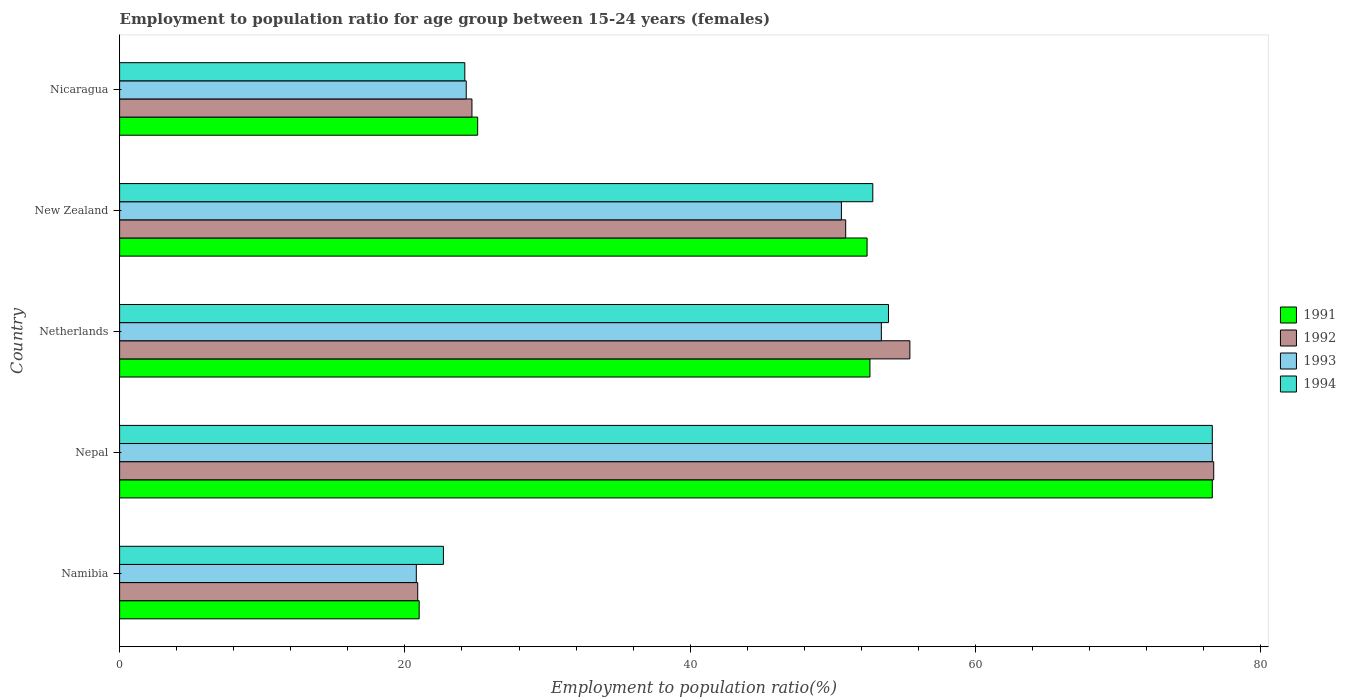How many groups of bars are there?
Give a very brief answer. 5. How many bars are there on the 2nd tick from the bottom?
Ensure brevity in your answer.  4. What is the label of the 1st group of bars from the top?
Your answer should be very brief. Nicaragua. What is the employment to population ratio in 1994 in Nicaragua?
Ensure brevity in your answer.  24.2. Across all countries, what is the maximum employment to population ratio in 1992?
Your answer should be very brief. 76.7. Across all countries, what is the minimum employment to population ratio in 1994?
Your answer should be compact. 22.7. In which country was the employment to population ratio in 1991 maximum?
Ensure brevity in your answer.  Nepal. In which country was the employment to population ratio in 1991 minimum?
Offer a terse response. Namibia. What is the total employment to population ratio in 1992 in the graph?
Offer a very short reply. 228.6. What is the difference between the employment to population ratio in 1991 in New Zealand and that in Nicaragua?
Your response must be concise. 27.3. What is the difference between the employment to population ratio in 1994 in Nepal and the employment to population ratio in 1992 in Netherlands?
Your answer should be compact. 21.2. What is the average employment to population ratio in 1992 per country?
Ensure brevity in your answer.  45.72. What is the difference between the employment to population ratio in 1991 and employment to population ratio in 1993 in New Zealand?
Provide a succinct answer. 1.8. In how many countries, is the employment to population ratio in 1993 greater than 20 %?
Offer a very short reply. 5. What is the ratio of the employment to population ratio in 1994 in Namibia to that in Netherlands?
Make the answer very short. 0.42. Is the employment to population ratio in 1991 in New Zealand less than that in Nicaragua?
Provide a succinct answer. No. Is the difference between the employment to population ratio in 1991 in Netherlands and Nicaragua greater than the difference between the employment to population ratio in 1993 in Netherlands and Nicaragua?
Offer a terse response. No. What is the difference between the highest and the second highest employment to population ratio in 1992?
Ensure brevity in your answer.  21.3. What is the difference between the highest and the lowest employment to population ratio in 1993?
Ensure brevity in your answer.  55.8. Is the sum of the employment to population ratio in 1993 in Namibia and New Zealand greater than the maximum employment to population ratio in 1992 across all countries?
Give a very brief answer. No. Are all the bars in the graph horizontal?
Your response must be concise. Yes. How many countries are there in the graph?
Offer a terse response. 5. What is the difference between two consecutive major ticks on the X-axis?
Offer a very short reply. 20. Are the values on the major ticks of X-axis written in scientific E-notation?
Offer a very short reply. No. Does the graph contain any zero values?
Your response must be concise. No. How many legend labels are there?
Your answer should be very brief. 4. What is the title of the graph?
Keep it short and to the point. Employment to population ratio for age group between 15-24 years (females). Does "1987" appear as one of the legend labels in the graph?
Keep it short and to the point. No. What is the label or title of the X-axis?
Your answer should be very brief. Employment to population ratio(%). What is the Employment to population ratio(%) in 1991 in Namibia?
Give a very brief answer. 21. What is the Employment to population ratio(%) in 1992 in Namibia?
Make the answer very short. 20.9. What is the Employment to population ratio(%) of 1993 in Namibia?
Your answer should be compact. 20.8. What is the Employment to population ratio(%) in 1994 in Namibia?
Your answer should be compact. 22.7. What is the Employment to population ratio(%) of 1991 in Nepal?
Your answer should be compact. 76.6. What is the Employment to population ratio(%) in 1992 in Nepal?
Offer a terse response. 76.7. What is the Employment to population ratio(%) in 1993 in Nepal?
Make the answer very short. 76.6. What is the Employment to population ratio(%) in 1994 in Nepal?
Your answer should be very brief. 76.6. What is the Employment to population ratio(%) of 1991 in Netherlands?
Keep it short and to the point. 52.6. What is the Employment to population ratio(%) in 1992 in Netherlands?
Provide a succinct answer. 55.4. What is the Employment to population ratio(%) of 1993 in Netherlands?
Give a very brief answer. 53.4. What is the Employment to population ratio(%) of 1994 in Netherlands?
Provide a succinct answer. 53.9. What is the Employment to population ratio(%) in 1991 in New Zealand?
Offer a terse response. 52.4. What is the Employment to population ratio(%) of 1992 in New Zealand?
Give a very brief answer. 50.9. What is the Employment to population ratio(%) in 1993 in New Zealand?
Provide a short and direct response. 50.6. What is the Employment to population ratio(%) of 1994 in New Zealand?
Your answer should be very brief. 52.8. What is the Employment to population ratio(%) in 1991 in Nicaragua?
Make the answer very short. 25.1. What is the Employment to population ratio(%) in 1992 in Nicaragua?
Your response must be concise. 24.7. What is the Employment to population ratio(%) of 1993 in Nicaragua?
Give a very brief answer. 24.3. What is the Employment to population ratio(%) of 1994 in Nicaragua?
Ensure brevity in your answer.  24.2. Across all countries, what is the maximum Employment to population ratio(%) of 1991?
Your answer should be very brief. 76.6. Across all countries, what is the maximum Employment to population ratio(%) in 1992?
Ensure brevity in your answer.  76.7. Across all countries, what is the maximum Employment to population ratio(%) of 1993?
Make the answer very short. 76.6. Across all countries, what is the maximum Employment to population ratio(%) in 1994?
Offer a very short reply. 76.6. Across all countries, what is the minimum Employment to population ratio(%) of 1991?
Offer a terse response. 21. Across all countries, what is the minimum Employment to population ratio(%) of 1992?
Make the answer very short. 20.9. Across all countries, what is the minimum Employment to population ratio(%) in 1993?
Give a very brief answer. 20.8. Across all countries, what is the minimum Employment to population ratio(%) in 1994?
Your answer should be very brief. 22.7. What is the total Employment to population ratio(%) of 1991 in the graph?
Give a very brief answer. 227.7. What is the total Employment to population ratio(%) of 1992 in the graph?
Your answer should be very brief. 228.6. What is the total Employment to population ratio(%) in 1993 in the graph?
Your answer should be compact. 225.7. What is the total Employment to population ratio(%) in 1994 in the graph?
Ensure brevity in your answer.  230.2. What is the difference between the Employment to population ratio(%) in 1991 in Namibia and that in Nepal?
Offer a very short reply. -55.6. What is the difference between the Employment to population ratio(%) in 1992 in Namibia and that in Nepal?
Make the answer very short. -55.8. What is the difference between the Employment to population ratio(%) in 1993 in Namibia and that in Nepal?
Offer a very short reply. -55.8. What is the difference between the Employment to population ratio(%) of 1994 in Namibia and that in Nepal?
Make the answer very short. -53.9. What is the difference between the Employment to population ratio(%) in 1991 in Namibia and that in Netherlands?
Your answer should be compact. -31.6. What is the difference between the Employment to population ratio(%) of 1992 in Namibia and that in Netherlands?
Provide a succinct answer. -34.5. What is the difference between the Employment to population ratio(%) of 1993 in Namibia and that in Netherlands?
Give a very brief answer. -32.6. What is the difference between the Employment to population ratio(%) of 1994 in Namibia and that in Netherlands?
Keep it short and to the point. -31.2. What is the difference between the Employment to population ratio(%) in 1991 in Namibia and that in New Zealand?
Provide a succinct answer. -31.4. What is the difference between the Employment to population ratio(%) of 1992 in Namibia and that in New Zealand?
Offer a very short reply. -30. What is the difference between the Employment to population ratio(%) of 1993 in Namibia and that in New Zealand?
Provide a short and direct response. -29.8. What is the difference between the Employment to population ratio(%) in 1994 in Namibia and that in New Zealand?
Offer a very short reply. -30.1. What is the difference between the Employment to population ratio(%) in 1992 in Namibia and that in Nicaragua?
Offer a very short reply. -3.8. What is the difference between the Employment to population ratio(%) in 1993 in Namibia and that in Nicaragua?
Ensure brevity in your answer.  -3.5. What is the difference between the Employment to population ratio(%) of 1992 in Nepal and that in Netherlands?
Your response must be concise. 21.3. What is the difference between the Employment to population ratio(%) of 1993 in Nepal and that in Netherlands?
Offer a very short reply. 23.2. What is the difference between the Employment to population ratio(%) of 1994 in Nepal and that in Netherlands?
Keep it short and to the point. 22.7. What is the difference between the Employment to population ratio(%) of 1991 in Nepal and that in New Zealand?
Provide a short and direct response. 24.2. What is the difference between the Employment to population ratio(%) of 1992 in Nepal and that in New Zealand?
Offer a terse response. 25.8. What is the difference between the Employment to population ratio(%) of 1993 in Nepal and that in New Zealand?
Your answer should be very brief. 26. What is the difference between the Employment to population ratio(%) of 1994 in Nepal and that in New Zealand?
Offer a terse response. 23.8. What is the difference between the Employment to population ratio(%) of 1991 in Nepal and that in Nicaragua?
Keep it short and to the point. 51.5. What is the difference between the Employment to population ratio(%) of 1993 in Nepal and that in Nicaragua?
Provide a short and direct response. 52.3. What is the difference between the Employment to population ratio(%) of 1994 in Nepal and that in Nicaragua?
Give a very brief answer. 52.4. What is the difference between the Employment to population ratio(%) of 1994 in Netherlands and that in New Zealand?
Give a very brief answer. 1.1. What is the difference between the Employment to population ratio(%) of 1991 in Netherlands and that in Nicaragua?
Ensure brevity in your answer.  27.5. What is the difference between the Employment to population ratio(%) in 1992 in Netherlands and that in Nicaragua?
Your answer should be very brief. 30.7. What is the difference between the Employment to population ratio(%) in 1993 in Netherlands and that in Nicaragua?
Provide a succinct answer. 29.1. What is the difference between the Employment to population ratio(%) in 1994 in Netherlands and that in Nicaragua?
Your answer should be very brief. 29.7. What is the difference between the Employment to population ratio(%) of 1991 in New Zealand and that in Nicaragua?
Offer a terse response. 27.3. What is the difference between the Employment to population ratio(%) of 1992 in New Zealand and that in Nicaragua?
Make the answer very short. 26.2. What is the difference between the Employment to population ratio(%) of 1993 in New Zealand and that in Nicaragua?
Keep it short and to the point. 26.3. What is the difference between the Employment to population ratio(%) in 1994 in New Zealand and that in Nicaragua?
Your answer should be compact. 28.6. What is the difference between the Employment to population ratio(%) of 1991 in Namibia and the Employment to population ratio(%) of 1992 in Nepal?
Offer a terse response. -55.7. What is the difference between the Employment to population ratio(%) in 1991 in Namibia and the Employment to population ratio(%) in 1993 in Nepal?
Provide a short and direct response. -55.6. What is the difference between the Employment to population ratio(%) of 1991 in Namibia and the Employment to population ratio(%) of 1994 in Nepal?
Provide a succinct answer. -55.6. What is the difference between the Employment to population ratio(%) in 1992 in Namibia and the Employment to population ratio(%) in 1993 in Nepal?
Your response must be concise. -55.7. What is the difference between the Employment to population ratio(%) in 1992 in Namibia and the Employment to population ratio(%) in 1994 in Nepal?
Ensure brevity in your answer.  -55.7. What is the difference between the Employment to population ratio(%) in 1993 in Namibia and the Employment to population ratio(%) in 1994 in Nepal?
Make the answer very short. -55.8. What is the difference between the Employment to population ratio(%) in 1991 in Namibia and the Employment to population ratio(%) in 1992 in Netherlands?
Your answer should be compact. -34.4. What is the difference between the Employment to population ratio(%) of 1991 in Namibia and the Employment to population ratio(%) of 1993 in Netherlands?
Give a very brief answer. -32.4. What is the difference between the Employment to population ratio(%) in 1991 in Namibia and the Employment to population ratio(%) in 1994 in Netherlands?
Provide a succinct answer. -32.9. What is the difference between the Employment to population ratio(%) in 1992 in Namibia and the Employment to population ratio(%) in 1993 in Netherlands?
Offer a very short reply. -32.5. What is the difference between the Employment to population ratio(%) in 1992 in Namibia and the Employment to population ratio(%) in 1994 in Netherlands?
Give a very brief answer. -33. What is the difference between the Employment to population ratio(%) of 1993 in Namibia and the Employment to population ratio(%) of 1994 in Netherlands?
Provide a succinct answer. -33.1. What is the difference between the Employment to population ratio(%) in 1991 in Namibia and the Employment to population ratio(%) in 1992 in New Zealand?
Keep it short and to the point. -29.9. What is the difference between the Employment to population ratio(%) of 1991 in Namibia and the Employment to population ratio(%) of 1993 in New Zealand?
Give a very brief answer. -29.6. What is the difference between the Employment to population ratio(%) of 1991 in Namibia and the Employment to population ratio(%) of 1994 in New Zealand?
Your answer should be compact. -31.8. What is the difference between the Employment to population ratio(%) in 1992 in Namibia and the Employment to population ratio(%) in 1993 in New Zealand?
Keep it short and to the point. -29.7. What is the difference between the Employment to population ratio(%) of 1992 in Namibia and the Employment to population ratio(%) of 1994 in New Zealand?
Offer a terse response. -31.9. What is the difference between the Employment to population ratio(%) of 1993 in Namibia and the Employment to population ratio(%) of 1994 in New Zealand?
Offer a terse response. -32. What is the difference between the Employment to population ratio(%) in 1991 in Namibia and the Employment to population ratio(%) in 1992 in Nicaragua?
Your response must be concise. -3.7. What is the difference between the Employment to population ratio(%) of 1992 in Namibia and the Employment to population ratio(%) of 1993 in Nicaragua?
Keep it short and to the point. -3.4. What is the difference between the Employment to population ratio(%) in 1992 in Namibia and the Employment to population ratio(%) in 1994 in Nicaragua?
Your response must be concise. -3.3. What is the difference between the Employment to population ratio(%) in 1993 in Namibia and the Employment to population ratio(%) in 1994 in Nicaragua?
Offer a very short reply. -3.4. What is the difference between the Employment to population ratio(%) in 1991 in Nepal and the Employment to population ratio(%) in 1992 in Netherlands?
Your response must be concise. 21.2. What is the difference between the Employment to population ratio(%) of 1991 in Nepal and the Employment to population ratio(%) of 1993 in Netherlands?
Your answer should be compact. 23.2. What is the difference between the Employment to population ratio(%) of 1991 in Nepal and the Employment to population ratio(%) of 1994 in Netherlands?
Provide a succinct answer. 22.7. What is the difference between the Employment to population ratio(%) in 1992 in Nepal and the Employment to population ratio(%) in 1993 in Netherlands?
Ensure brevity in your answer.  23.3. What is the difference between the Employment to population ratio(%) in 1992 in Nepal and the Employment to population ratio(%) in 1994 in Netherlands?
Keep it short and to the point. 22.8. What is the difference between the Employment to population ratio(%) of 1993 in Nepal and the Employment to population ratio(%) of 1994 in Netherlands?
Provide a short and direct response. 22.7. What is the difference between the Employment to population ratio(%) in 1991 in Nepal and the Employment to population ratio(%) in 1992 in New Zealand?
Ensure brevity in your answer.  25.7. What is the difference between the Employment to population ratio(%) in 1991 in Nepal and the Employment to population ratio(%) in 1994 in New Zealand?
Provide a succinct answer. 23.8. What is the difference between the Employment to population ratio(%) in 1992 in Nepal and the Employment to population ratio(%) in 1993 in New Zealand?
Provide a short and direct response. 26.1. What is the difference between the Employment to population ratio(%) in 1992 in Nepal and the Employment to population ratio(%) in 1994 in New Zealand?
Make the answer very short. 23.9. What is the difference between the Employment to population ratio(%) in 1993 in Nepal and the Employment to population ratio(%) in 1994 in New Zealand?
Offer a terse response. 23.8. What is the difference between the Employment to population ratio(%) of 1991 in Nepal and the Employment to population ratio(%) of 1992 in Nicaragua?
Keep it short and to the point. 51.9. What is the difference between the Employment to population ratio(%) of 1991 in Nepal and the Employment to population ratio(%) of 1993 in Nicaragua?
Give a very brief answer. 52.3. What is the difference between the Employment to population ratio(%) of 1991 in Nepal and the Employment to population ratio(%) of 1994 in Nicaragua?
Offer a terse response. 52.4. What is the difference between the Employment to population ratio(%) in 1992 in Nepal and the Employment to population ratio(%) in 1993 in Nicaragua?
Make the answer very short. 52.4. What is the difference between the Employment to population ratio(%) in 1992 in Nepal and the Employment to population ratio(%) in 1994 in Nicaragua?
Offer a terse response. 52.5. What is the difference between the Employment to population ratio(%) of 1993 in Nepal and the Employment to population ratio(%) of 1994 in Nicaragua?
Your answer should be compact. 52.4. What is the difference between the Employment to population ratio(%) in 1991 in Netherlands and the Employment to population ratio(%) in 1993 in New Zealand?
Ensure brevity in your answer.  2. What is the difference between the Employment to population ratio(%) of 1991 in Netherlands and the Employment to population ratio(%) of 1994 in New Zealand?
Give a very brief answer. -0.2. What is the difference between the Employment to population ratio(%) of 1992 in Netherlands and the Employment to population ratio(%) of 1994 in New Zealand?
Your response must be concise. 2.6. What is the difference between the Employment to population ratio(%) in 1991 in Netherlands and the Employment to population ratio(%) in 1992 in Nicaragua?
Offer a terse response. 27.9. What is the difference between the Employment to population ratio(%) of 1991 in Netherlands and the Employment to population ratio(%) of 1993 in Nicaragua?
Offer a terse response. 28.3. What is the difference between the Employment to population ratio(%) of 1991 in Netherlands and the Employment to population ratio(%) of 1994 in Nicaragua?
Your answer should be very brief. 28.4. What is the difference between the Employment to population ratio(%) of 1992 in Netherlands and the Employment to population ratio(%) of 1993 in Nicaragua?
Keep it short and to the point. 31.1. What is the difference between the Employment to population ratio(%) of 1992 in Netherlands and the Employment to population ratio(%) of 1994 in Nicaragua?
Give a very brief answer. 31.2. What is the difference between the Employment to population ratio(%) in 1993 in Netherlands and the Employment to population ratio(%) in 1994 in Nicaragua?
Your response must be concise. 29.2. What is the difference between the Employment to population ratio(%) in 1991 in New Zealand and the Employment to population ratio(%) in 1992 in Nicaragua?
Your response must be concise. 27.7. What is the difference between the Employment to population ratio(%) of 1991 in New Zealand and the Employment to population ratio(%) of 1993 in Nicaragua?
Give a very brief answer. 28.1. What is the difference between the Employment to population ratio(%) in 1991 in New Zealand and the Employment to population ratio(%) in 1994 in Nicaragua?
Provide a short and direct response. 28.2. What is the difference between the Employment to population ratio(%) in 1992 in New Zealand and the Employment to population ratio(%) in 1993 in Nicaragua?
Ensure brevity in your answer.  26.6. What is the difference between the Employment to population ratio(%) in 1992 in New Zealand and the Employment to population ratio(%) in 1994 in Nicaragua?
Provide a short and direct response. 26.7. What is the difference between the Employment to population ratio(%) in 1993 in New Zealand and the Employment to population ratio(%) in 1994 in Nicaragua?
Make the answer very short. 26.4. What is the average Employment to population ratio(%) in 1991 per country?
Make the answer very short. 45.54. What is the average Employment to population ratio(%) in 1992 per country?
Provide a succinct answer. 45.72. What is the average Employment to population ratio(%) of 1993 per country?
Offer a very short reply. 45.14. What is the average Employment to population ratio(%) of 1994 per country?
Your answer should be very brief. 46.04. What is the difference between the Employment to population ratio(%) of 1991 and Employment to population ratio(%) of 1992 in Namibia?
Offer a terse response. 0.1. What is the difference between the Employment to population ratio(%) in 1992 and Employment to population ratio(%) in 1994 in Namibia?
Your answer should be very brief. -1.8. What is the difference between the Employment to population ratio(%) in 1993 and Employment to population ratio(%) in 1994 in Namibia?
Offer a terse response. -1.9. What is the difference between the Employment to population ratio(%) in 1991 and Employment to population ratio(%) in 1992 in Nepal?
Provide a short and direct response. -0.1. What is the difference between the Employment to population ratio(%) of 1991 and Employment to population ratio(%) of 1993 in Nepal?
Your response must be concise. 0. What is the difference between the Employment to population ratio(%) in 1991 and Employment to population ratio(%) in 1992 in Netherlands?
Make the answer very short. -2.8. What is the difference between the Employment to population ratio(%) of 1992 and Employment to population ratio(%) of 1993 in Netherlands?
Offer a terse response. 2. What is the difference between the Employment to population ratio(%) in 1992 and Employment to population ratio(%) in 1994 in Netherlands?
Provide a short and direct response. 1.5. What is the difference between the Employment to population ratio(%) of 1991 and Employment to population ratio(%) of 1992 in New Zealand?
Make the answer very short. 1.5. What is the difference between the Employment to population ratio(%) in 1991 and Employment to population ratio(%) in 1993 in New Zealand?
Offer a very short reply. 1.8. What is the difference between the Employment to population ratio(%) of 1993 and Employment to population ratio(%) of 1994 in New Zealand?
Your answer should be very brief. -2.2. What is the difference between the Employment to population ratio(%) in 1991 and Employment to population ratio(%) in 1992 in Nicaragua?
Provide a succinct answer. 0.4. What is the difference between the Employment to population ratio(%) in 1991 and Employment to population ratio(%) in 1993 in Nicaragua?
Offer a terse response. 0.8. What is the difference between the Employment to population ratio(%) in 1991 and Employment to population ratio(%) in 1994 in Nicaragua?
Ensure brevity in your answer.  0.9. What is the difference between the Employment to population ratio(%) in 1992 and Employment to population ratio(%) in 1994 in Nicaragua?
Provide a short and direct response. 0.5. What is the difference between the Employment to population ratio(%) of 1993 and Employment to population ratio(%) of 1994 in Nicaragua?
Your answer should be compact. 0.1. What is the ratio of the Employment to population ratio(%) in 1991 in Namibia to that in Nepal?
Your response must be concise. 0.27. What is the ratio of the Employment to population ratio(%) in 1992 in Namibia to that in Nepal?
Your answer should be very brief. 0.27. What is the ratio of the Employment to population ratio(%) of 1993 in Namibia to that in Nepal?
Your response must be concise. 0.27. What is the ratio of the Employment to population ratio(%) of 1994 in Namibia to that in Nepal?
Your answer should be very brief. 0.3. What is the ratio of the Employment to population ratio(%) in 1991 in Namibia to that in Netherlands?
Make the answer very short. 0.4. What is the ratio of the Employment to population ratio(%) in 1992 in Namibia to that in Netherlands?
Your answer should be very brief. 0.38. What is the ratio of the Employment to population ratio(%) in 1993 in Namibia to that in Netherlands?
Provide a succinct answer. 0.39. What is the ratio of the Employment to population ratio(%) in 1994 in Namibia to that in Netherlands?
Ensure brevity in your answer.  0.42. What is the ratio of the Employment to population ratio(%) of 1991 in Namibia to that in New Zealand?
Your response must be concise. 0.4. What is the ratio of the Employment to population ratio(%) in 1992 in Namibia to that in New Zealand?
Keep it short and to the point. 0.41. What is the ratio of the Employment to population ratio(%) of 1993 in Namibia to that in New Zealand?
Provide a succinct answer. 0.41. What is the ratio of the Employment to population ratio(%) of 1994 in Namibia to that in New Zealand?
Your answer should be compact. 0.43. What is the ratio of the Employment to population ratio(%) in 1991 in Namibia to that in Nicaragua?
Ensure brevity in your answer.  0.84. What is the ratio of the Employment to population ratio(%) in 1992 in Namibia to that in Nicaragua?
Give a very brief answer. 0.85. What is the ratio of the Employment to population ratio(%) in 1993 in Namibia to that in Nicaragua?
Your response must be concise. 0.86. What is the ratio of the Employment to population ratio(%) of 1994 in Namibia to that in Nicaragua?
Your response must be concise. 0.94. What is the ratio of the Employment to population ratio(%) in 1991 in Nepal to that in Netherlands?
Provide a succinct answer. 1.46. What is the ratio of the Employment to population ratio(%) in 1992 in Nepal to that in Netherlands?
Ensure brevity in your answer.  1.38. What is the ratio of the Employment to population ratio(%) in 1993 in Nepal to that in Netherlands?
Make the answer very short. 1.43. What is the ratio of the Employment to population ratio(%) in 1994 in Nepal to that in Netherlands?
Offer a terse response. 1.42. What is the ratio of the Employment to population ratio(%) of 1991 in Nepal to that in New Zealand?
Offer a very short reply. 1.46. What is the ratio of the Employment to population ratio(%) in 1992 in Nepal to that in New Zealand?
Your response must be concise. 1.51. What is the ratio of the Employment to population ratio(%) in 1993 in Nepal to that in New Zealand?
Ensure brevity in your answer.  1.51. What is the ratio of the Employment to population ratio(%) in 1994 in Nepal to that in New Zealand?
Your answer should be very brief. 1.45. What is the ratio of the Employment to population ratio(%) in 1991 in Nepal to that in Nicaragua?
Give a very brief answer. 3.05. What is the ratio of the Employment to population ratio(%) of 1992 in Nepal to that in Nicaragua?
Offer a terse response. 3.11. What is the ratio of the Employment to population ratio(%) of 1993 in Nepal to that in Nicaragua?
Give a very brief answer. 3.15. What is the ratio of the Employment to population ratio(%) in 1994 in Nepal to that in Nicaragua?
Make the answer very short. 3.17. What is the ratio of the Employment to population ratio(%) of 1991 in Netherlands to that in New Zealand?
Offer a terse response. 1. What is the ratio of the Employment to population ratio(%) of 1992 in Netherlands to that in New Zealand?
Offer a terse response. 1.09. What is the ratio of the Employment to population ratio(%) of 1993 in Netherlands to that in New Zealand?
Offer a terse response. 1.06. What is the ratio of the Employment to population ratio(%) in 1994 in Netherlands to that in New Zealand?
Provide a succinct answer. 1.02. What is the ratio of the Employment to population ratio(%) in 1991 in Netherlands to that in Nicaragua?
Offer a terse response. 2.1. What is the ratio of the Employment to population ratio(%) of 1992 in Netherlands to that in Nicaragua?
Your response must be concise. 2.24. What is the ratio of the Employment to population ratio(%) of 1993 in Netherlands to that in Nicaragua?
Ensure brevity in your answer.  2.2. What is the ratio of the Employment to population ratio(%) of 1994 in Netherlands to that in Nicaragua?
Keep it short and to the point. 2.23. What is the ratio of the Employment to population ratio(%) of 1991 in New Zealand to that in Nicaragua?
Your answer should be compact. 2.09. What is the ratio of the Employment to population ratio(%) in 1992 in New Zealand to that in Nicaragua?
Give a very brief answer. 2.06. What is the ratio of the Employment to population ratio(%) of 1993 in New Zealand to that in Nicaragua?
Your response must be concise. 2.08. What is the ratio of the Employment to population ratio(%) of 1994 in New Zealand to that in Nicaragua?
Provide a succinct answer. 2.18. What is the difference between the highest and the second highest Employment to population ratio(%) in 1992?
Offer a very short reply. 21.3. What is the difference between the highest and the second highest Employment to population ratio(%) in 1993?
Give a very brief answer. 23.2. What is the difference between the highest and the second highest Employment to population ratio(%) in 1994?
Give a very brief answer. 22.7. What is the difference between the highest and the lowest Employment to population ratio(%) of 1991?
Your response must be concise. 55.6. What is the difference between the highest and the lowest Employment to population ratio(%) of 1992?
Your answer should be compact. 55.8. What is the difference between the highest and the lowest Employment to population ratio(%) of 1993?
Ensure brevity in your answer.  55.8. What is the difference between the highest and the lowest Employment to population ratio(%) of 1994?
Provide a succinct answer. 53.9. 